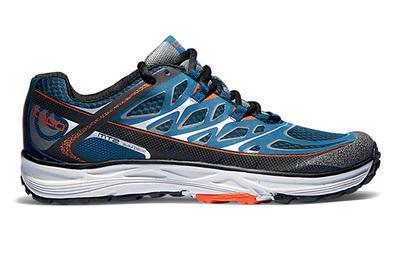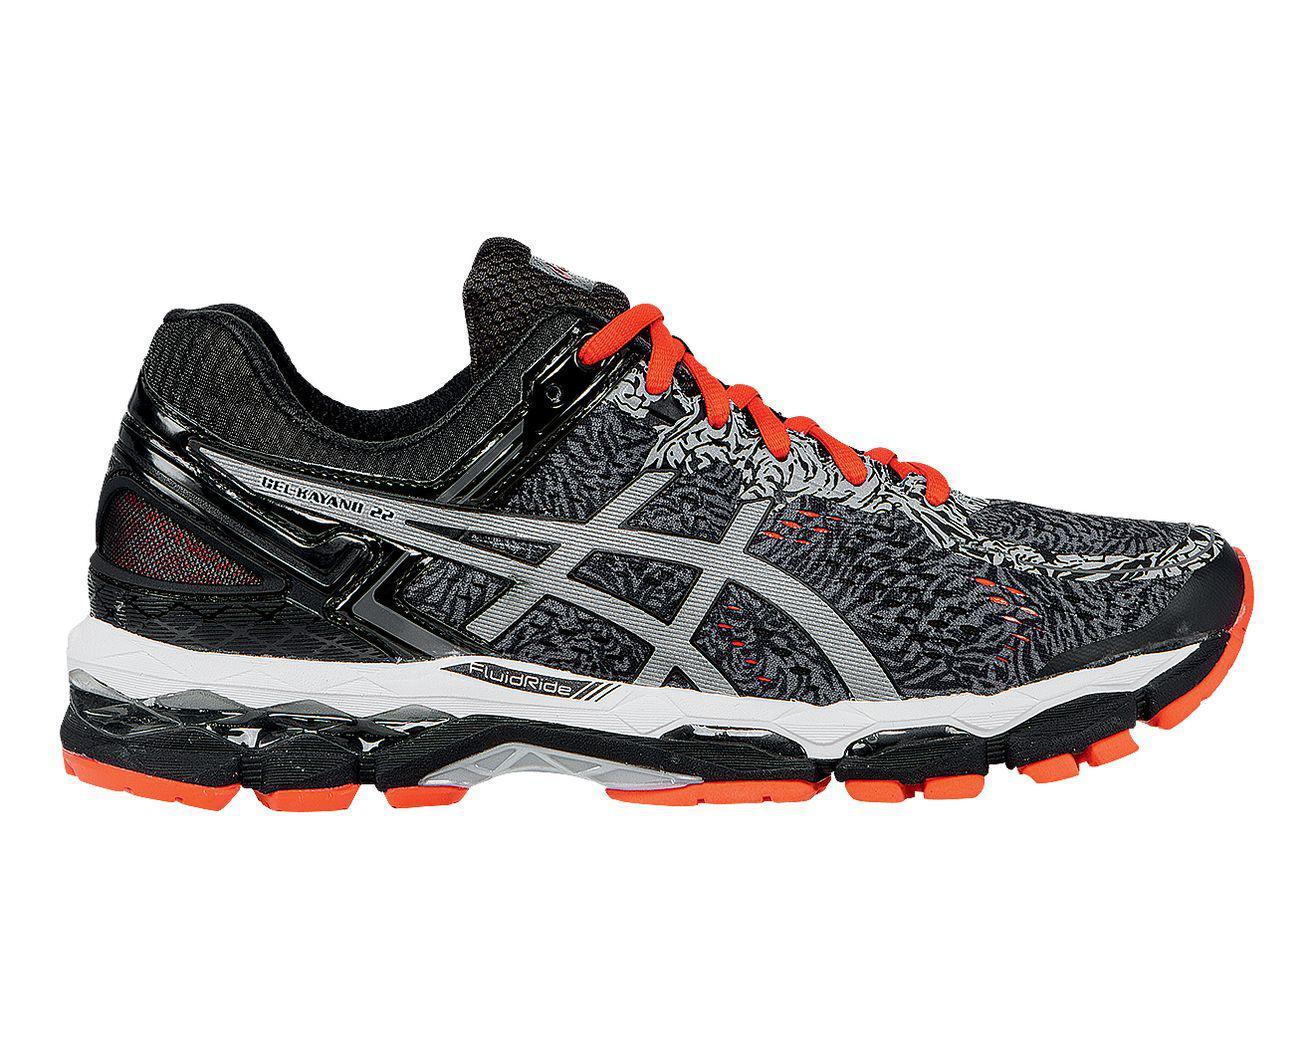The first image is the image on the left, the second image is the image on the right. Analyze the images presented: Is the assertion "Exactly one shoe has a blue heel." valid? Answer yes or no. No. 